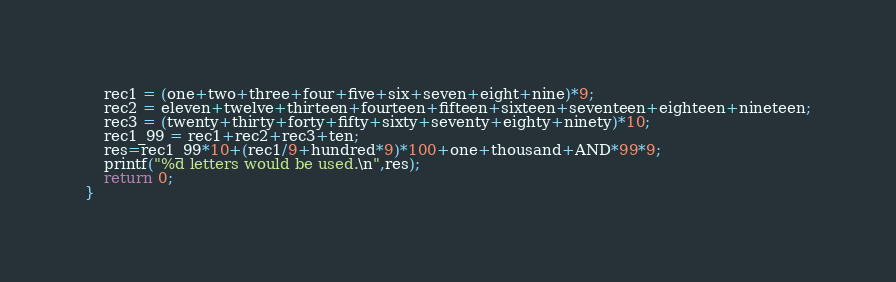<code> <loc_0><loc_0><loc_500><loc_500><_C++_>    rec1 = (one+two+three+four+five+six+seven+eight+nine)*9;
    rec2 = eleven+twelve+thirteen+fourteen+fifteen+sixteen+seventeen+eighteen+nineteen;
    rec3 = (twenty+thirty+forty+fifty+sixty+seventy+eighty+ninety)*10;
    rec1_99 = rec1+rec2+rec3+ten;
    res=rec1_99*10+(rec1/9+hundred*9)*100+one+thousand+AND*99*9;
    printf("%d letters would be used.\n",res);
    return 0;
}
</code> 